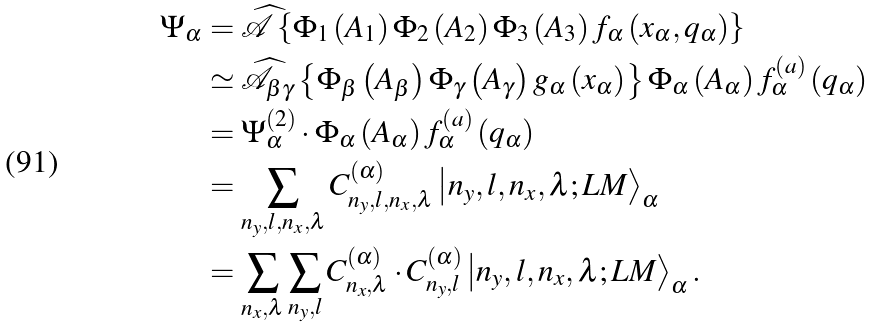Convert formula to latex. <formula><loc_0><loc_0><loc_500><loc_500>\Psi _ { \alpha } & = \widehat { \mathcal { A } } \left \{ \Phi _ { 1 } \left ( A _ { 1 } \right ) \Phi _ { 2 } \left ( A _ { 2 } \right ) \Phi _ { 3 } \left ( A _ { 3 } \right ) f _ { \alpha } \left ( x _ { \alpha } , q _ { \alpha } \right ) \right \} \\ & \simeq \widehat { \mathcal { A } } _ { \beta \gamma } \left \{ \Phi _ { \beta } \left ( A _ { \beta } \right ) \Phi _ { \gamma } \left ( A _ { \gamma } \right ) g _ { \alpha } \left ( x _ { \alpha } \right ) \right \} \Phi _ { \alpha } \left ( A _ { \alpha } \right ) f _ { \alpha } ^ { \left ( a \right ) } \left ( q _ { \alpha } \right ) \\ & = \Psi _ { \alpha } ^ { \left ( 2 \right ) } \cdot \Phi _ { \alpha } \left ( A _ { \alpha } \right ) f _ { \alpha } ^ { \left ( a \right ) } \left ( q _ { \alpha } \right ) \\ & = \sum _ { n _ { y } , l , n _ { x } , \lambda } C _ { n _ { y } , l , n _ { x } , \lambda } ^ { \left ( \alpha \right ) } \left | n _ { y } , l , n _ { x } , \lambda ; L M \right \rangle _ { \alpha } \\ & = \sum _ { n _ { x } , \lambda } \sum _ { n _ { y } , l } C _ { n _ { x } , \lambda } ^ { \left ( \alpha \right ) } \cdot C _ { n _ { y } , l } ^ { \left ( \alpha \right ) } \left | n _ { y } , l , n _ { x } , \lambda ; L M \right \rangle _ { \alpha } .</formula> 